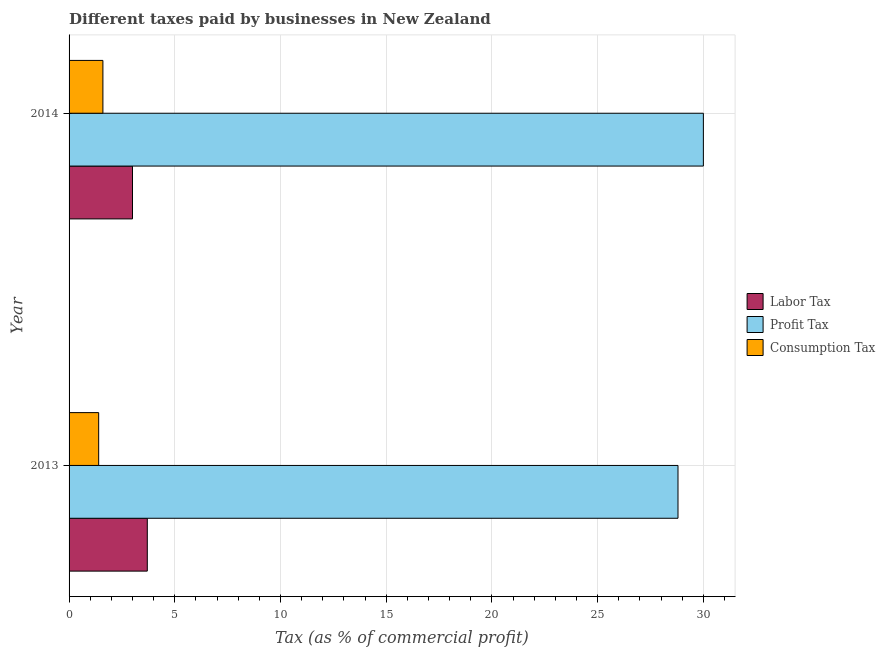How many groups of bars are there?
Give a very brief answer. 2. Are the number of bars per tick equal to the number of legend labels?
Ensure brevity in your answer.  Yes. Are the number of bars on each tick of the Y-axis equal?
Keep it short and to the point. Yes. How many bars are there on the 2nd tick from the bottom?
Provide a short and direct response. 3. What is the label of the 1st group of bars from the top?
Offer a very short reply. 2014. In how many cases, is the number of bars for a given year not equal to the number of legend labels?
Your answer should be very brief. 0. What is the percentage of labor tax in 2013?
Offer a very short reply. 3.7. In which year was the percentage of profit tax maximum?
Provide a succinct answer. 2014. In which year was the percentage of consumption tax minimum?
Keep it short and to the point. 2013. What is the difference between the percentage of labor tax in 2013 and the percentage of consumption tax in 2014?
Your answer should be compact. 2.1. What is the average percentage of profit tax per year?
Keep it short and to the point. 29.4. In the year 2013, what is the difference between the percentage of profit tax and percentage of labor tax?
Give a very brief answer. 25.1. What is the ratio of the percentage of profit tax in 2013 to that in 2014?
Your answer should be compact. 0.96. Is the percentage of profit tax in 2013 less than that in 2014?
Provide a succinct answer. Yes. What does the 3rd bar from the top in 2014 represents?
Make the answer very short. Labor Tax. What does the 3rd bar from the bottom in 2013 represents?
Offer a very short reply. Consumption Tax. How many years are there in the graph?
Offer a terse response. 2. What is the difference between two consecutive major ticks on the X-axis?
Offer a terse response. 5. Does the graph contain grids?
Your response must be concise. Yes. How many legend labels are there?
Your answer should be compact. 3. What is the title of the graph?
Provide a short and direct response. Different taxes paid by businesses in New Zealand. What is the label or title of the X-axis?
Offer a terse response. Tax (as % of commercial profit). What is the label or title of the Y-axis?
Give a very brief answer. Year. What is the Tax (as % of commercial profit) of Profit Tax in 2013?
Keep it short and to the point. 28.8. What is the Tax (as % of commercial profit) in Labor Tax in 2014?
Your answer should be very brief. 3. What is the Tax (as % of commercial profit) in Profit Tax in 2014?
Provide a succinct answer. 30. What is the Tax (as % of commercial profit) of Consumption Tax in 2014?
Give a very brief answer. 1.6. Across all years, what is the maximum Tax (as % of commercial profit) in Labor Tax?
Your response must be concise. 3.7. Across all years, what is the minimum Tax (as % of commercial profit) of Labor Tax?
Make the answer very short. 3. Across all years, what is the minimum Tax (as % of commercial profit) in Profit Tax?
Offer a very short reply. 28.8. What is the total Tax (as % of commercial profit) of Labor Tax in the graph?
Your answer should be very brief. 6.7. What is the total Tax (as % of commercial profit) of Profit Tax in the graph?
Ensure brevity in your answer.  58.8. What is the total Tax (as % of commercial profit) in Consumption Tax in the graph?
Keep it short and to the point. 3. What is the difference between the Tax (as % of commercial profit) in Labor Tax in 2013 and that in 2014?
Offer a terse response. 0.7. What is the difference between the Tax (as % of commercial profit) of Profit Tax in 2013 and that in 2014?
Offer a terse response. -1.2. What is the difference between the Tax (as % of commercial profit) of Labor Tax in 2013 and the Tax (as % of commercial profit) of Profit Tax in 2014?
Your answer should be compact. -26.3. What is the difference between the Tax (as % of commercial profit) in Profit Tax in 2013 and the Tax (as % of commercial profit) in Consumption Tax in 2014?
Make the answer very short. 27.2. What is the average Tax (as % of commercial profit) of Labor Tax per year?
Keep it short and to the point. 3.35. What is the average Tax (as % of commercial profit) in Profit Tax per year?
Your answer should be compact. 29.4. What is the average Tax (as % of commercial profit) in Consumption Tax per year?
Keep it short and to the point. 1.5. In the year 2013, what is the difference between the Tax (as % of commercial profit) of Labor Tax and Tax (as % of commercial profit) of Profit Tax?
Make the answer very short. -25.1. In the year 2013, what is the difference between the Tax (as % of commercial profit) in Labor Tax and Tax (as % of commercial profit) in Consumption Tax?
Ensure brevity in your answer.  2.3. In the year 2013, what is the difference between the Tax (as % of commercial profit) in Profit Tax and Tax (as % of commercial profit) in Consumption Tax?
Keep it short and to the point. 27.4. In the year 2014, what is the difference between the Tax (as % of commercial profit) in Labor Tax and Tax (as % of commercial profit) in Profit Tax?
Provide a short and direct response. -27. In the year 2014, what is the difference between the Tax (as % of commercial profit) in Labor Tax and Tax (as % of commercial profit) in Consumption Tax?
Your answer should be very brief. 1.4. In the year 2014, what is the difference between the Tax (as % of commercial profit) in Profit Tax and Tax (as % of commercial profit) in Consumption Tax?
Your answer should be compact. 28.4. What is the ratio of the Tax (as % of commercial profit) in Labor Tax in 2013 to that in 2014?
Make the answer very short. 1.23. What is the difference between the highest and the lowest Tax (as % of commercial profit) of Labor Tax?
Keep it short and to the point. 0.7. 